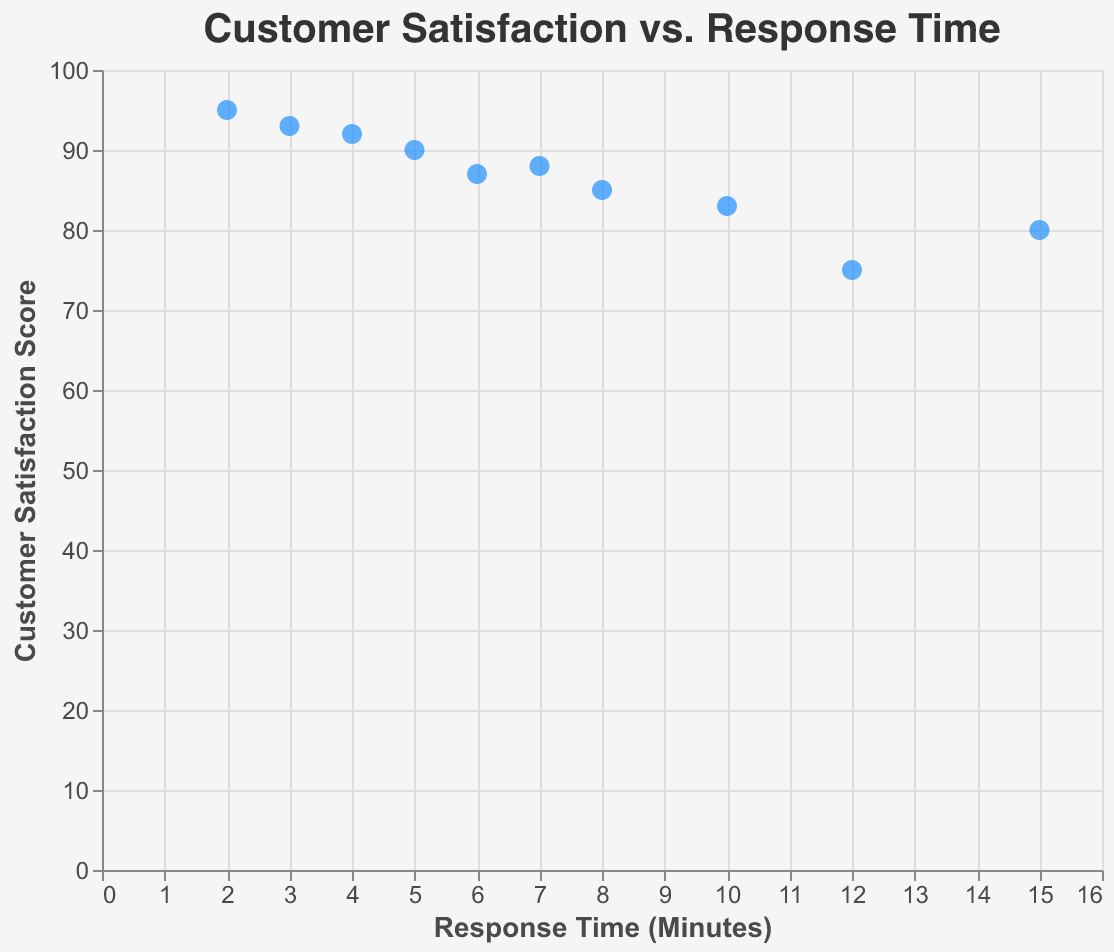What is the title of the scatter plot? The title is located at the top of the scatter plot and helps to understand the focus of the visual data.
Answer: Customer Satisfaction vs. Response Time How many customer data points are present in the scatter plot? By counting the number of points (or marks) displayed on the scatter plot, we can identify the number of customer data points.
Answer: 10 Which customer had the shortest response time, and what was their satisfaction score? By observing the x-axis values (Response Time) and checking for the smallest value, we find the corresponding customer and look at the y-axis (Customer Satisfaction) to find their satisfaction score.
Answer: FastFix Services, 95 What is the average response time among all the customers? Add up all the response times and divide by the number of customers. The response times are: 5 + 15 + 8 + 2 + 10 + 3 + 7 + 12 + 4 + 6 which sums to 72. Dividing by 10 customers gives 72 / 10 = 7.2.
Answer: 7.2 minutes Which two customers have the closest satisfaction scores, and what are those scores? By comparing the subtracted differences between the satisfaction scores of all customers, we find the smallest difference. Visionary Support (92) and Quick Response Ltd (93) have the closest scores, with a difference of 1.
Answer: Visionary Support and Quick Response Ltd, 92 and 93 What is the correlation between response time and customer satisfaction? By observing the general trend in the scatter plot, we can determine if there's a positive or negative correlation. As the response time decreases, the satisfaction score tends to increase, indicating a negative correlation.
Answer: Negative correlation Which customer had the highest satisfaction score and what was their response time? Check the highest point on the y-axis (Customer Satisfaction) and identify the corresponding x-axis value (Response Time).
Answer: FastFix Services, 2 minutes How does Zenith Solutions' satisfaction score compare to BrightFuture Inc.'s satisfaction score? Compare the y-axis values for Zenith Solutions (80) and BrightFuture Inc. (83) to determine which is higher.
Answer: BrightFuture Inc. has a higher score By how many minutes is the response time of First Choice Services greater than that of PrimeAssist? Subtract the response time of PrimeAssist from the response time of First Choice Services: 12 - 6 = 6.
Answer: 6 minutes Identify the customer with the lowest satisfaction score and provide their response time. Look for the lowest point on the y-axis (Customer Satisfaction) and note the corresponding x-axis (Response Time) value.
Answer: First Choice Services, 12 minutes 